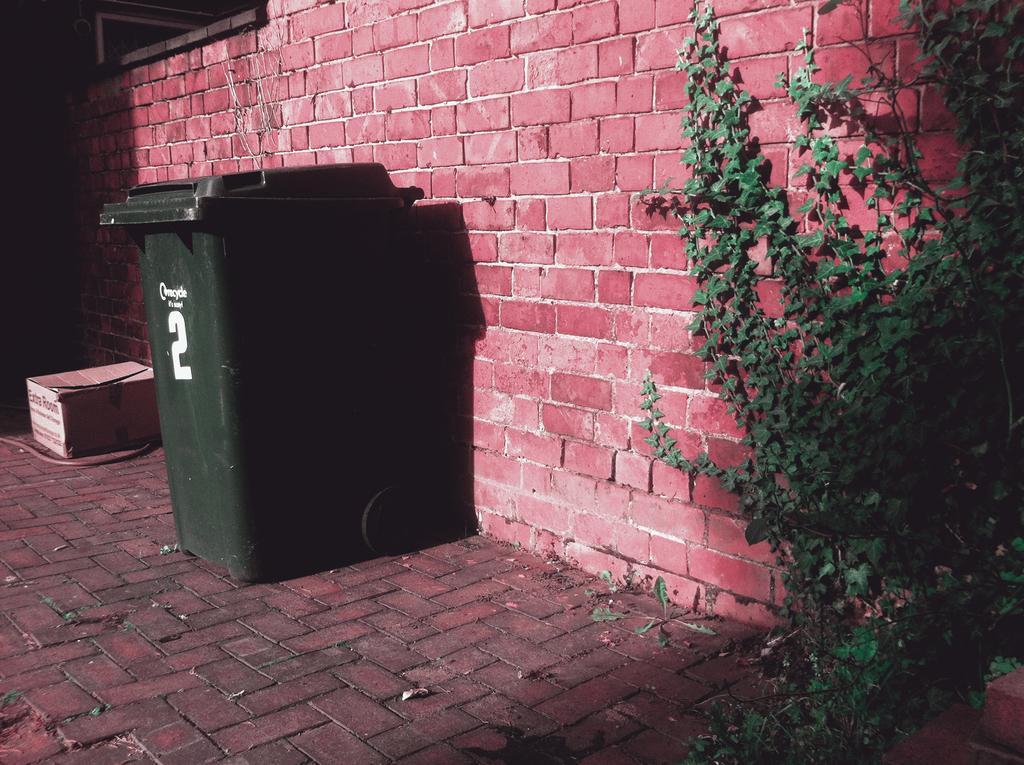Can you describe this image briefly? In this image there is a plastic dustbin in the middle of this image. There is a plant on the right side of this image. There is a box kept on the ground on the left side of this image. There is a wall in the background. There is a floor in the bottom of this image. 